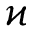<formula> <loc_0><loc_0><loc_500><loc_500>\varkappa</formula> 